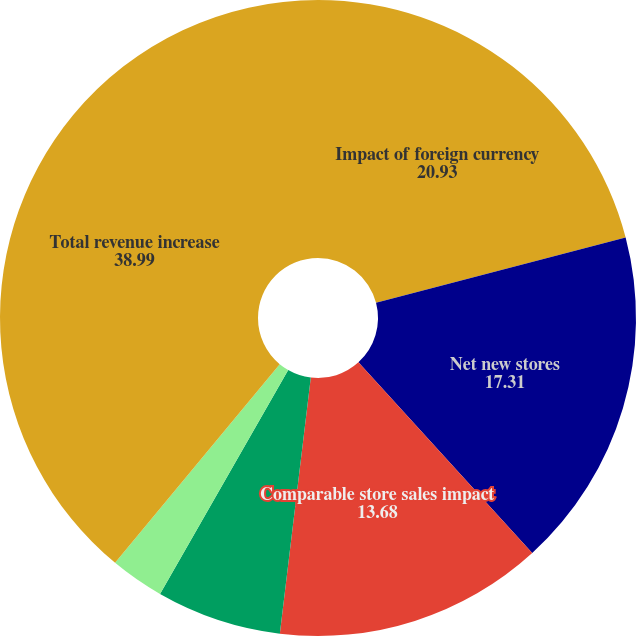<chart> <loc_0><loc_0><loc_500><loc_500><pie_chart><fcel>Impact of foreign currency<fcel>Net new stores<fcel>Comparable store sales impact<fcel>One less week of revenue for<fcel>Non-comparable sales channels<fcel>Total revenue increase<nl><fcel>20.93%<fcel>17.31%<fcel>13.68%<fcel>6.36%<fcel>2.74%<fcel>38.99%<nl></chart> 